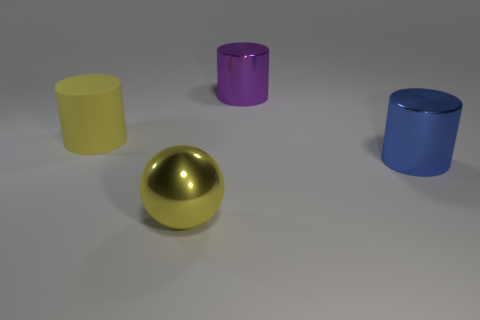Add 3 large yellow objects. How many objects exist? 7 Subtract all spheres. How many objects are left? 3 Subtract 0 green cubes. How many objects are left? 4 Subtract all tiny yellow shiny spheres. Subtract all matte objects. How many objects are left? 3 Add 1 spheres. How many spheres are left? 2 Add 3 big blue cylinders. How many big blue cylinders exist? 4 